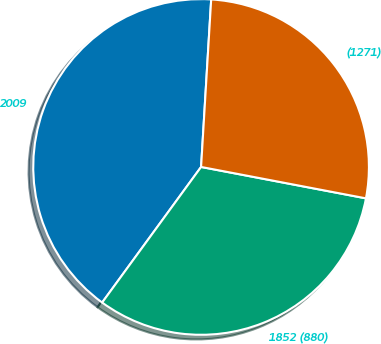Convert chart. <chart><loc_0><loc_0><loc_500><loc_500><pie_chart><fcel>2009<fcel>1852 (880)<fcel>(1271)<nl><fcel>40.93%<fcel>32.04%<fcel>27.04%<nl></chart> 